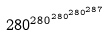<formula> <loc_0><loc_0><loc_500><loc_500>2 8 0 ^ { 2 8 0 ^ { 2 8 0 ^ { 2 8 0 ^ { 2 8 7 } } } }</formula> 